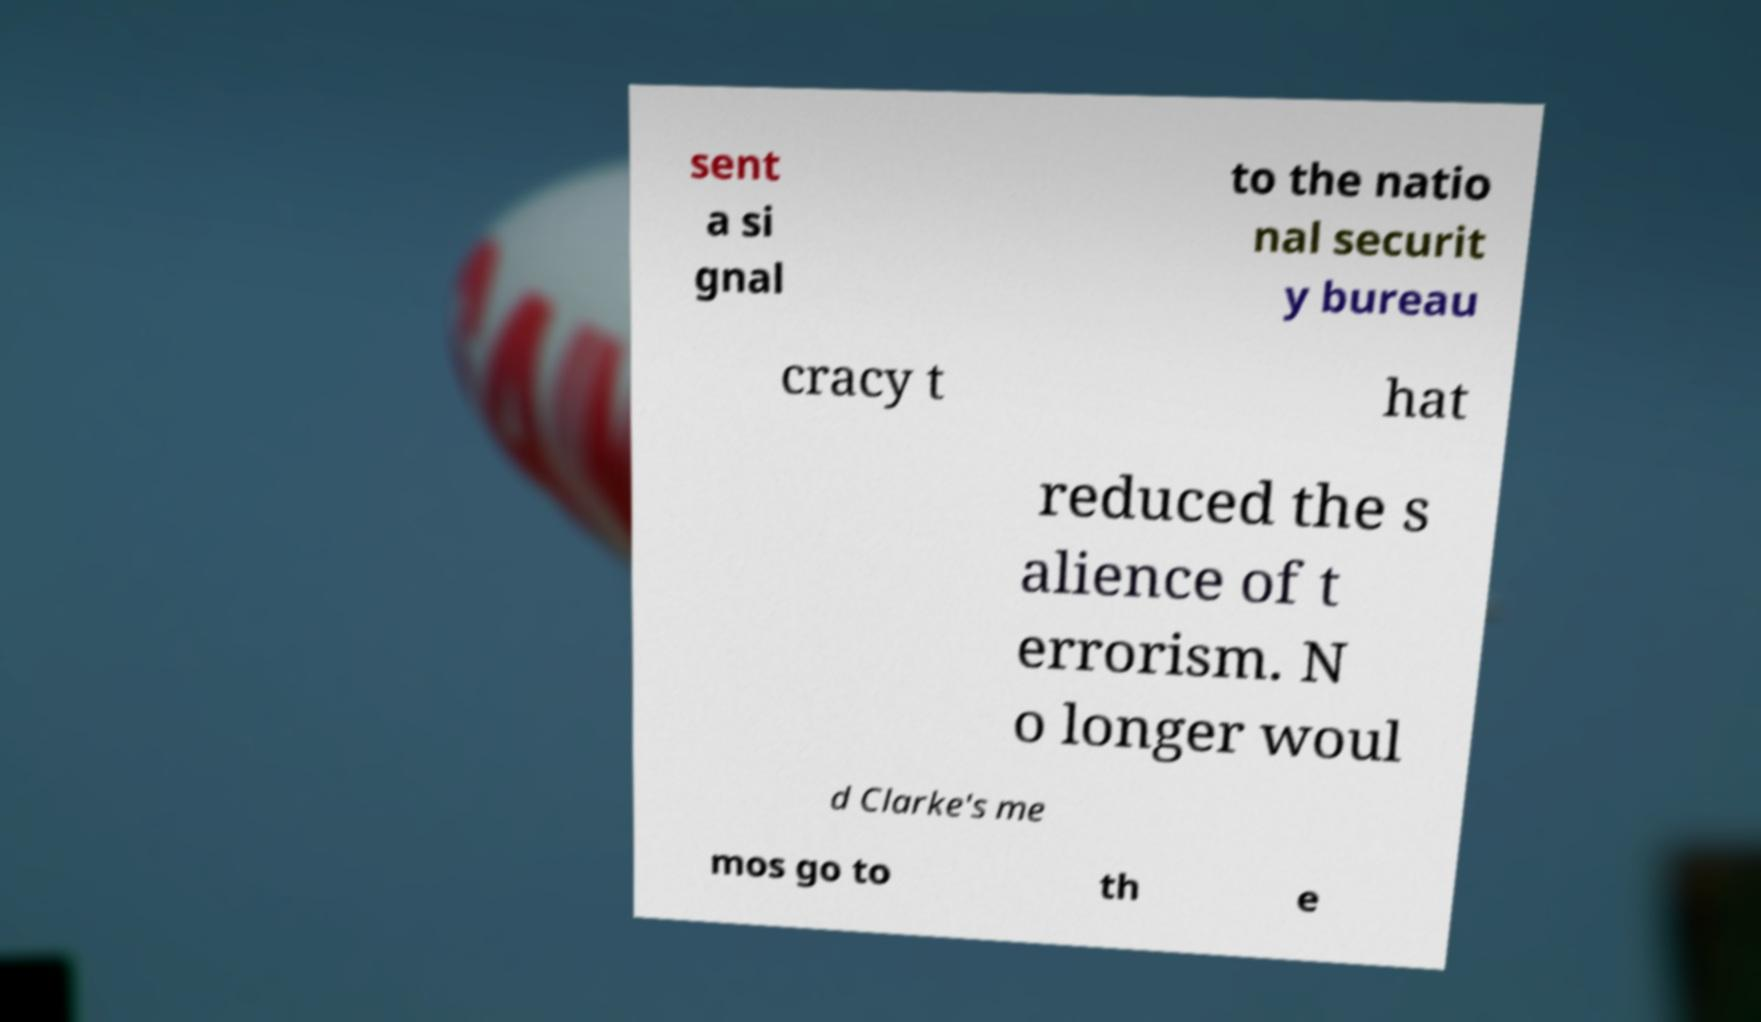I need the written content from this picture converted into text. Can you do that? sent a si gnal to the natio nal securit y bureau cracy t hat reduced the s alience of t errorism. N o longer woul d Clarke's me mos go to th e 